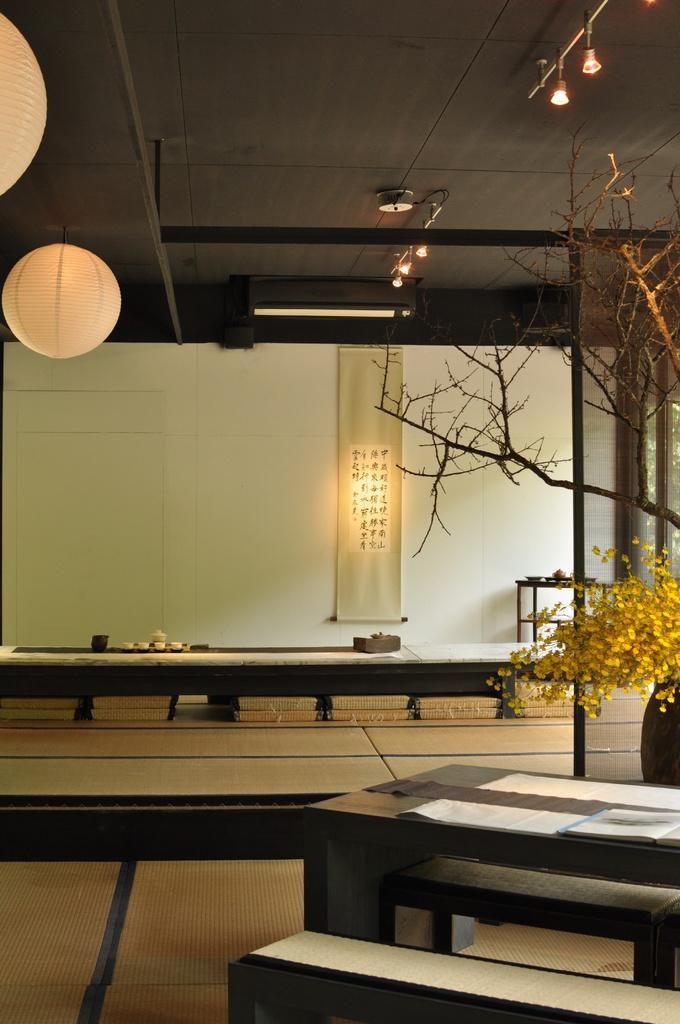Please provide a concise description of this image. In this picture we can see a few objects on the tables. There is a flower vase, tree stems, paper lanterns, benches, lights, some text on the fabric banner and other objects. 